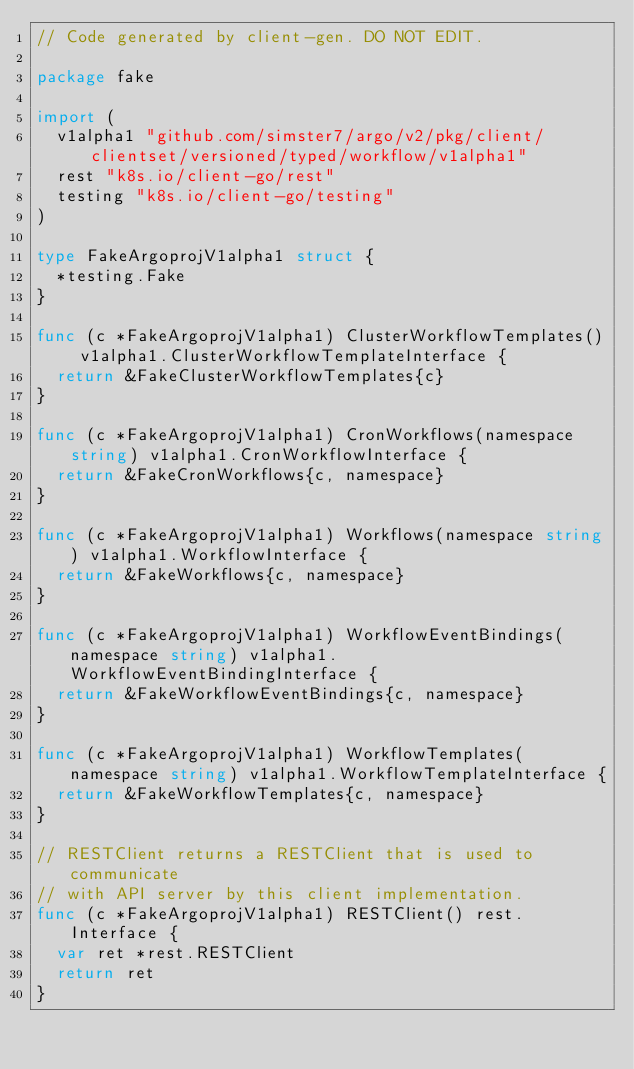<code> <loc_0><loc_0><loc_500><loc_500><_Go_>// Code generated by client-gen. DO NOT EDIT.

package fake

import (
	v1alpha1 "github.com/simster7/argo/v2/pkg/client/clientset/versioned/typed/workflow/v1alpha1"
	rest "k8s.io/client-go/rest"
	testing "k8s.io/client-go/testing"
)

type FakeArgoprojV1alpha1 struct {
	*testing.Fake
}

func (c *FakeArgoprojV1alpha1) ClusterWorkflowTemplates() v1alpha1.ClusterWorkflowTemplateInterface {
	return &FakeClusterWorkflowTemplates{c}
}

func (c *FakeArgoprojV1alpha1) CronWorkflows(namespace string) v1alpha1.CronWorkflowInterface {
	return &FakeCronWorkflows{c, namespace}
}

func (c *FakeArgoprojV1alpha1) Workflows(namespace string) v1alpha1.WorkflowInterface {
	return &FakeWorkflows{c, namespace}
}

func (c *FakeArgoprojV1alpha1) WorkflowEventBindings(namespace string) v1alpha1.WorkflowEventBindingInterface {
	return &FakeWorkflowEventBindings{c, namespace}
}

func (c *FakeArgoprojV1alpha1) WorkflowTemplates(namespace string) v1alpha1.WorkflowTemplateInterface {
	return &FakeWorkflowTemplates{c, namespace}
}

// RESTClient returns a RESTClient that is used to communicate
// with API server by this client implementation.
func (c *FakeArgoprojV1alpha1) RESTClient() rest.Interface {
	var ret *rest.RESTClient
	return ret
}
</code> 